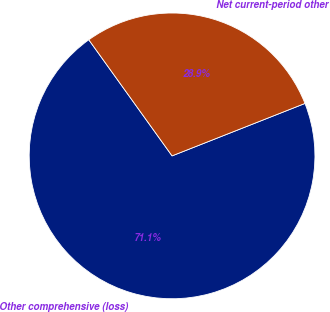<chart> <loc_0><loc_0><loc_500><loc_500><pie_chart><fcel>Other comprehensive (loss)<fcel>Net current-period other<nl><fcel>71.08%<fcel>28.92%<nl></chart> 